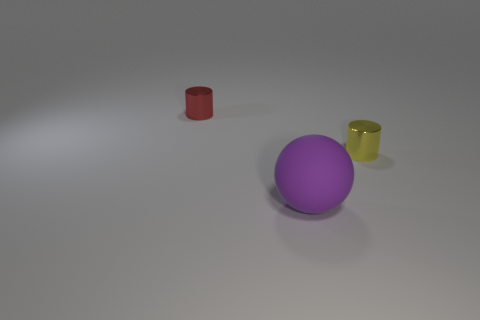Add 2 large matte balls. How many objects exist? 5 Subtract all cylinders. How many objects are left? 1 Subtract 1 cylinders. How many cylinders are left? 1 Subtract all brown cylinders. Subtract all purple blocks. How many cylinders are left? 2 Subtract all big green rubber cylinders. Subtract all red metal things. How many objects are left? 2 Add 3 rubber balls. How many rubber balls are left? 4 Add 2 big purple cylinders. How many big purple cylinders exist? 2 Subtract 1 red cylinders. How many objects are left? 2 